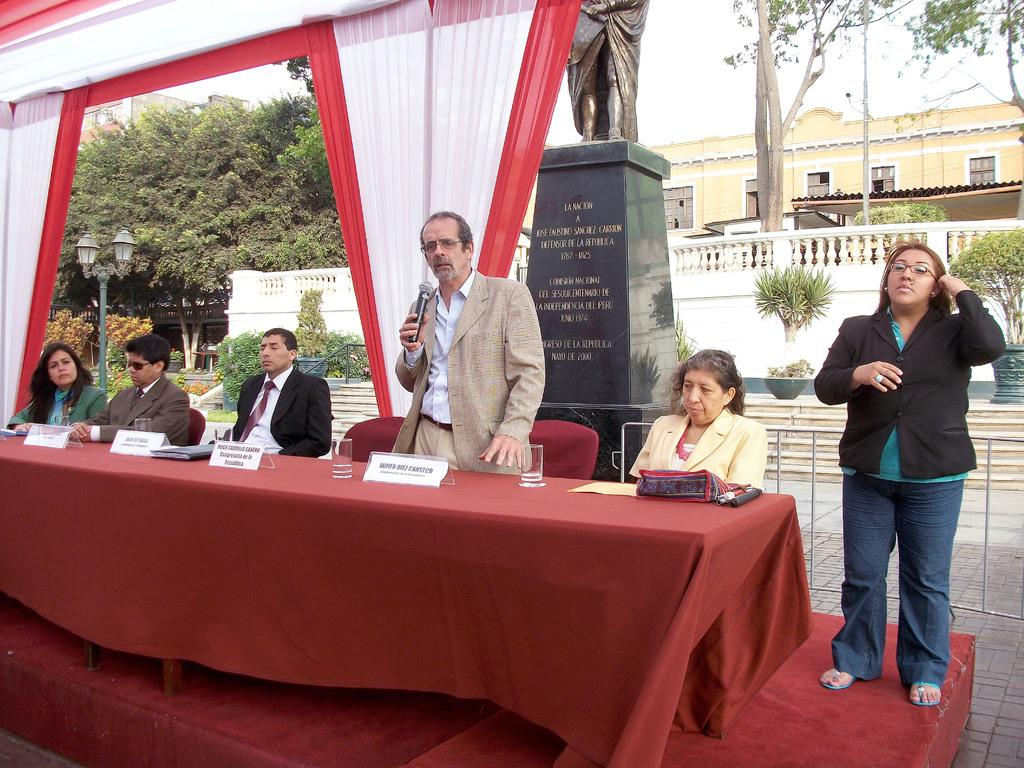How many people are in the group in the image? There is a group of 6 people in the image. Can you describe the gender distribution of the group? 3 of the people are men, and 3 of the people are women. What can be seen in the background of the image? There are trees, a street light, a house, and a statue in the background of the image. What channel is the group watching on the television in the image? There is no television present in the image, so it is not possible to determine what channel they might be watching. 